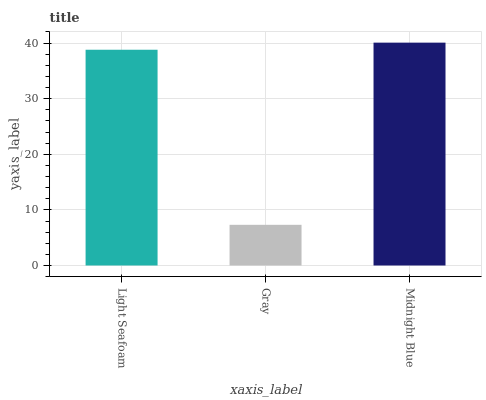Is Gray the minimum?
Answer yes or no. Yes. Is Midnight Blue the maximum?
Answer yes or no. Yes. Is Midnight Blue the minimum?
Answer yes or no. No. Is Gray the maximum?
Answer yes or no. No. Is Midnight Blue greater than Gray?
Answer yes or no. Yes. Is Gray less than Midnight Blue?
Answer yes or no. Yes. Is Gray greater than Midnight Blue?
Answer yes or no. No. Is Midnight Blue less than Gray?
Answer yes or no. No. Is Light Seafoam the high median?
Answer yes or no. Yes. Is Light Seafoam the low median?
Answer yes or no. Yes. Is Gray the high median?
Answer yes or no. No. Is Midnight Blue the low median?
Answer yes or no. No. 